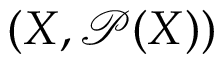Convert formula to latex. <formula><loc_0><loc_0><loc_500><loc_500>( X , { \mathcal { P } } ( X ) )</formula> 